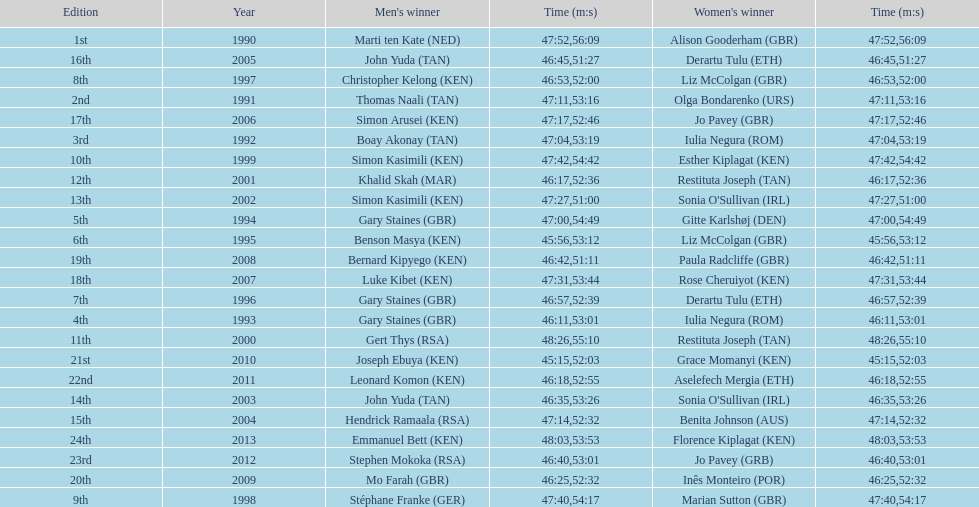Help me parse the entirety of this table. {'header': ['Edition', 'Year', "Men's winner", 'Time (m:s)', "Women's winner", 'Time (m:s)'], 'rows': [['1st', '1990', 'Marti ten Kate\xa0(NED)', '47:52', 'Alison Gooderham\xa0(GBR)', '56:09'], ['16th', '2005', 'John Yuda\xa0(TAN)', '46:45', 'Derartu Tulu\xa0(ETH)', '51:27'], ['8th', '1997', 'Christopher Kelong\xa0(KEN)', '46:53', 'Liz McColgan\xa0(GBR)', '52:00'], ['2nd', '1991', 'Thomas Naali\xa0(TAN)', '47:11', 'Olga Bondarenko\xa0(URS)', '53:16'], ['17th', '2006', 'Simon Arusei\xa0(KEN)', '47:17', 'Jo Pavey\xa0(GBR)', '52:46'], ['3rd', '1992', 'Boay Akonay\xa0(TAN)', '47:04', 'Iulia Negura\xa0(ROM)', '53:19'], ['10th', '1999', 'Simon Kasimili\xa0(KEN)', '47:42', 'Esther Kiplagat\xa0(KEN)', '54:42'], ['12th', '2001', 'Khalid Skah\xa0(MAR)', '46:17', 'Restituta Joseph\xa0(TAN)', '52:36'], ['13th', '2002', 'Simon Kasimili\xa0(KEN)', '47:27', "Sonia O'Sullivan\xa0(IRL)", '51:00'], ['5th', '1994', 'Gary Staines\xa0(GBR)', '47:00', 'Gitte Karlshøj\xa0(DEN)', '54:49'], ['6th', '1995', 'Benson Masya\xa0(KEN)', '45:56', 'Liz McColgan\xa0(GBR)', '53:12'], ['19th', '2008', 'Bernard Kipyego\xa0(KEN)', '46:42', 'Paula Radcliffe\xa0(GBR)', '51:11'], ['18th', '2007', 'Luke Kibet\xa0(KEN)', '47:31', 'Rose Cheruiyot\xa0(KEN)', '53:44'], ['7th', '1996', 'Gary Staines\xa0(GBR)', '46:57', 'Derartu Tulu\xa0(ETH)', '52:39'], ['4th', '1993', 'Gary Staines\xa0(GBR)', '46:11', 'Iulia Negura\xa0(ROM)', '53:01'], ['11th', '2000', 'Gert Thys\xa0(RSA)', '48:26', 'Restituta Joseph\xa0(TAN)', '55:10'], ['21st', '2010', 'Joseph Ebuya\xa0(KEN)', '45:15', 'Grace Momanyi\xa0(KEN)', '52:03'], ['22nd', '2011', 'Leonard Komon\xa0(KEN)', '46:18', 'Aselefech Mergia\xa0(ETH)', '52:55'], ['14th', '2003', 'John Yuda\xa0(TAN)', '46:35', "Sonia O'Sullivan\xa0(IRL)", '53:26'], ['15th', '2004', 'Hendrick Ramaala\xa0(RSA)', '47:14', 'Benita Johnson\xa0(AUS)', '52:32'], ['24th', '2013', 'Emmanuel Bett\xa0(KEN)', '48:03', 'Florence Kiplagat\xa0(KEN)', '53:53'], ['23rd', '2012', 'Stephen Mokoka\xa0(RSA)', '46:40', 'Jo Pavey\xa0(GRB)', '53:01'], ['20th', '2009', 'Mo Farah\xa0(GBR)', '46:25', 'Inês Monteiro\xa0(POR)', '52:32'], ['9th', '1998', 'Stéphane Franke\xa0(GER)', '47:40', 'Marian Sutton\xa0(GBR)', '54:17']]} The other women's winner with the same finish time as jo pavey in 2012 Iulia Negura. 